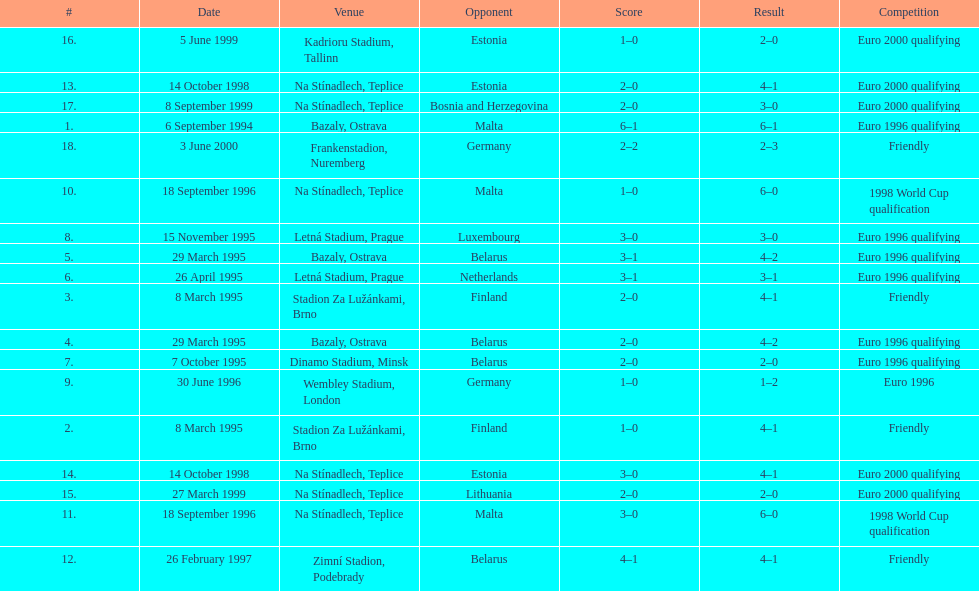Would you be able to parse every entry in this table? {'header': ['#', 'Date', 'Venue', 'Opponent', 'Score', 'Result', 'Competition'], 'rows': [['16.', '5 June 1999', 'Kadrioru Stadium, Tallinn', 'Estonia', '1–0', '2–0', 'Euro 2000 qualifying'], ['13.', '14 October 1998', 'Na Stínadlech, Teplice', 'Estonia', '2–0', '4–1', 'Euro 2000 qualifying'], ['17.', '8 September 1999', 'Na Stínadlech, Teplice', 'Bosnia and Herzegovina', '2–0', '3–0', 'Euro 2000 qualifying'], ['1.', '6 September 1994', 'Bazaly, Ostrava', 'Malta', '6–1', '6–1', 'Euro 1996 qualifying'], ['18.', '3 June 2000', 'Frankenstadion, Nuremberg', 'Germany', '2–2', '2–3', 'Friendly'], ['10.', '18 September 1996', 'Na Stínadlech, Teplice', 'Malta', '1–0', '6–0', '1998 World Cup qualification'], ['8.', '15 November 1995', 'Letná Stadium, Prague', 'Luxembourg', '3–0', '3–0', 'Euro 1996 qualifying'], ['5.', '29 March 1995', 'Bazaly, Ostrava', 'Belarus', '3–1', '4–2', 'Euro 1996 qualifying'], ['6.', '26 April 1995', 'Letná Stadium, Prague', 'Netherlands', '3–1', '3–1', 'Euro 1996 qualifying'], ['3.', '8 March 1995', 'Stadion Za Lužánkami, Brno', 'Finland', '2–0', '4–1', 'Friendly'], ['4.', '29 March 1995', 'Bazaly, Ostrava', 'Belarus', '2–0', '4–2', 'Euro 1996 qualifying'], ['7.', '7 October 1995', 'Dinamo Stadium, Minsk', 'Belarus', '2–0', '2–0', 'Euro 1996 qualifying'], ['9.', '30 June 1996', 'Wembley Stadium, London', 'Germany', '1–0', '1–2', 'Euro 1996'], ['2.', '8 March 1995', 'Stadion Za Lužánkami, Brno', 'Finland', '1–0', '4–1', 'Friendly'], ['14.', '14 October 1998', 'Na Stínadlech, Teplice', 'Estonia', '3–0', '4–1', 'Euro 2000 qualifying'], ['15.', '27 March 1999', 'Na Stínadlech, Teplice', 'Lithuania', '2–0', '2–0', 'Euro 2000 qualifying'], ['11.', '18 September 1996', 'Na Stínadlech, Teplice', 'Malta', '3–0', '6–0', '1998 World Cup qualification'], ['12.', '26 February 1997', 'Zimní Stadion, Podebrady', 'Belarus', '4–1', '4–1', 'Friendly']]} What venue is listed above wembley stadium, london? Letná Stadium, Prague. 